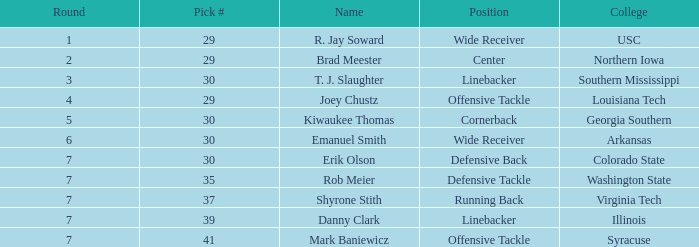What is the top choice for a wide receiver with an overall rating of 29? 29.0. 